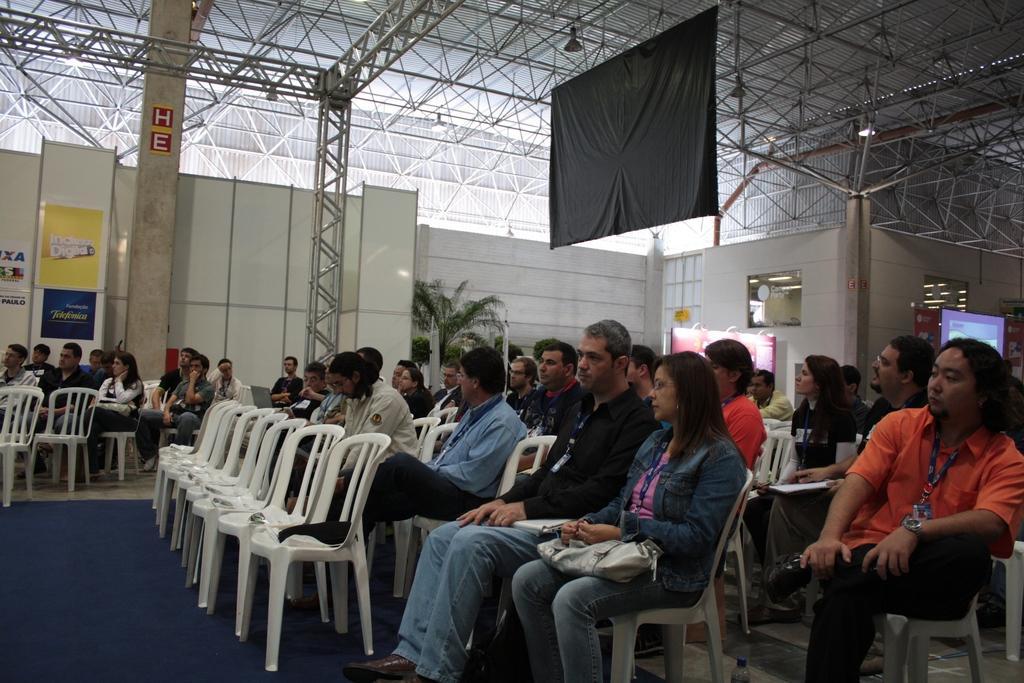Describe this image in one or two sentences. In this image i can see number of people sitting on chair, all of them are wearing identity cards in their necks, In the background i can see the wall,few posters, the roof,a screen and few lights. 